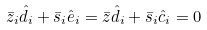Convert formula to latex. <formula><loc_0><loc_0><loc_500><loc_500>\bar { z } _ { i } \hat { d } _ { i } + \bar { s } _ { i } \hat { e } _ { i } = \bar { z } \hat { d } _ { i } + \bar { s } _ { i } \hat { c } _ { i } = 0</formula> 